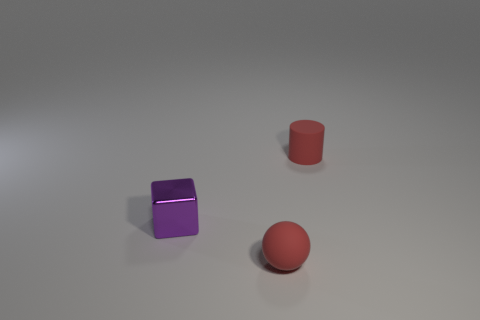Does the purple object that is behind the sphere have the same shape as the tiny red thing left of the tiny rubber cylinder?
Ensure brevity in your answer.  No. There is a matte object that is the same size as the red rubber sphere; what is its shape?
Keep it short and to the point. Cylinder. Is the small red thing right of the rubber sphere made of the same material as the thing in front of the small purple block?
Offer a very short reply. Yes. There is a small red thing that is in front of the cylinder; are there any balls that are in front of it?
Your response must be concise. No. There is a ball that is the same material as the small red cylinder; what color is it?
Make the answer very short. Red. Is the number of tiny cyan rubber blocks greater than the number of cubes?
Ensure brevity in your answer.  No. How many objects are things on the left side of the red matte ball or tiny purple objects?
Provide a short and direct response. 1. Is there a shiny cube that has the same size as the cylinder?
Make the answer very short. Yes. Are there fewer large gray balls than cubes?
Offer a terse response. Yes. What number of spheres are either purple objects or large red objects?
Make the answer very short. 0. 